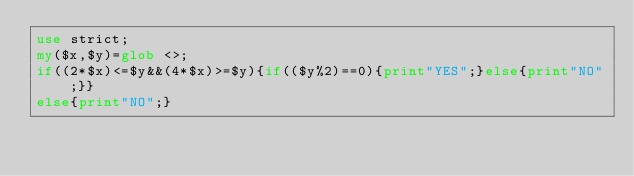Convert code to text. <code><loc_0><loc_0><loc_500><loc_500><_Perl_>use strict;
my($x,$y)=glob <>;
if((2*$x)<=$y&&(4*$x)>=$y){if(($y%2)==0){print"YES";}else{print"NO";}}
else{print"NO";}
</code> 